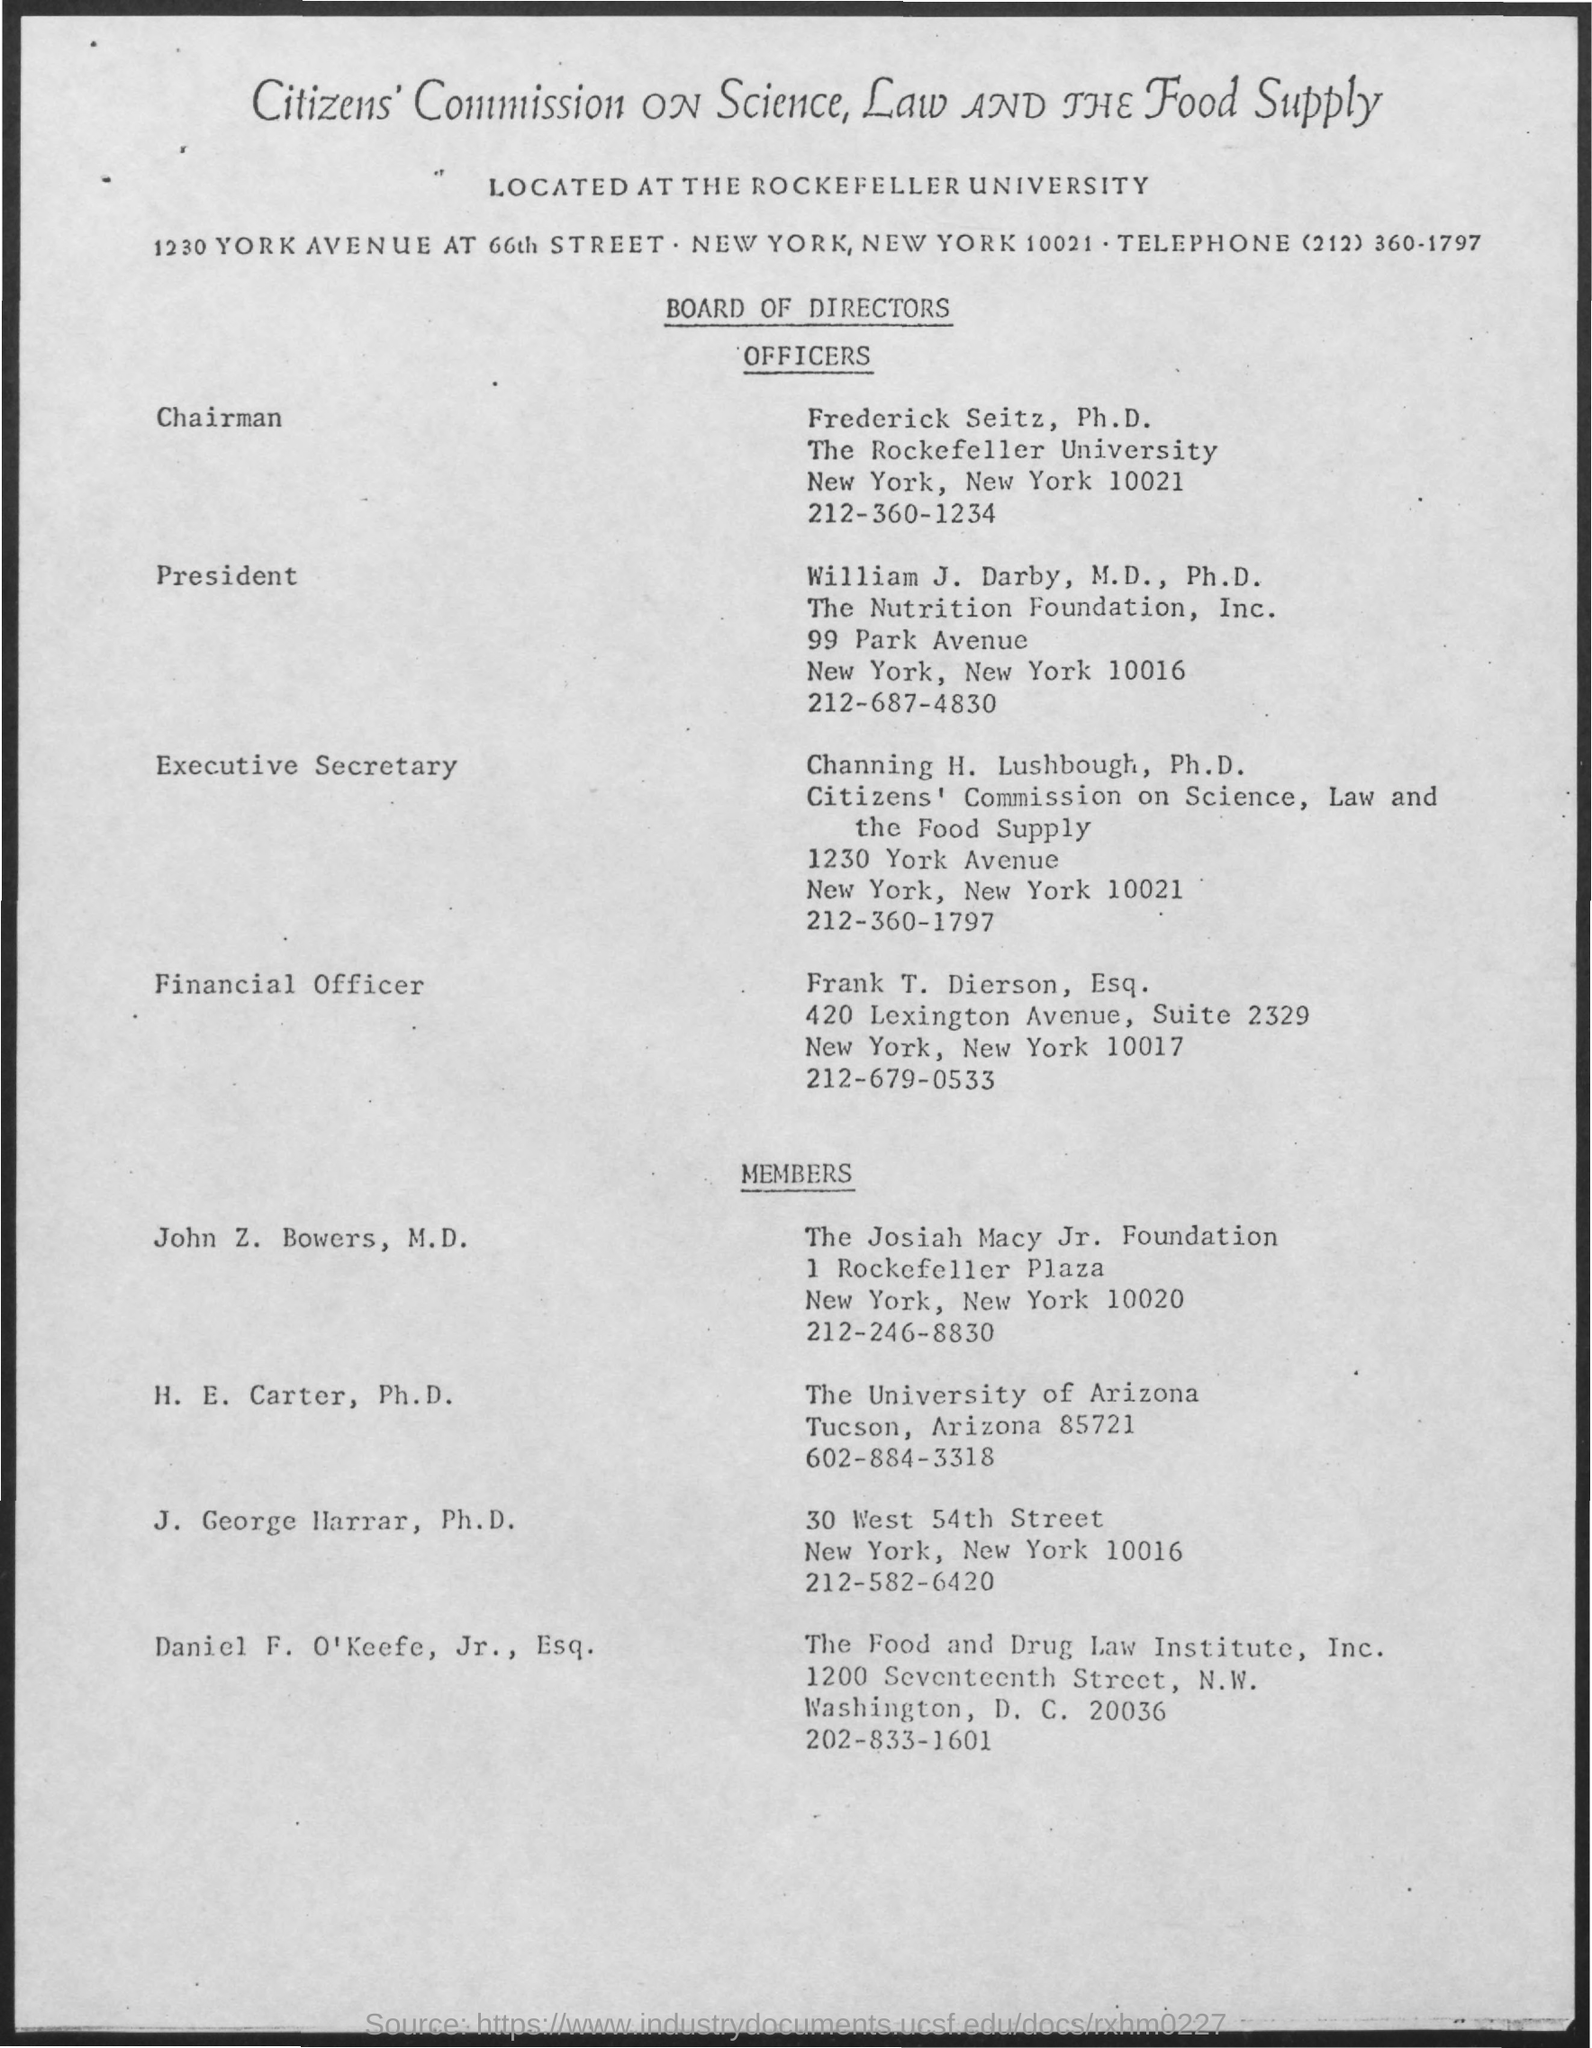What is the name of the president mentioned ?
Your answer should be very brief. William j. darby. What is the name of the executive secretary ?
Offer a very short reply. Channing h. lushbough. What is the name of the financial officer mentioned ?
Make the answer very short. Frank T. Dierson. 